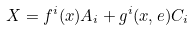Convert formula to latex. <formula><loc_0><loc_0><loc_500><loc_500>X = f ^ { i } ( x ) A _ { i } + g ^ { i } ( x , e ) C _ { i }</formula> 